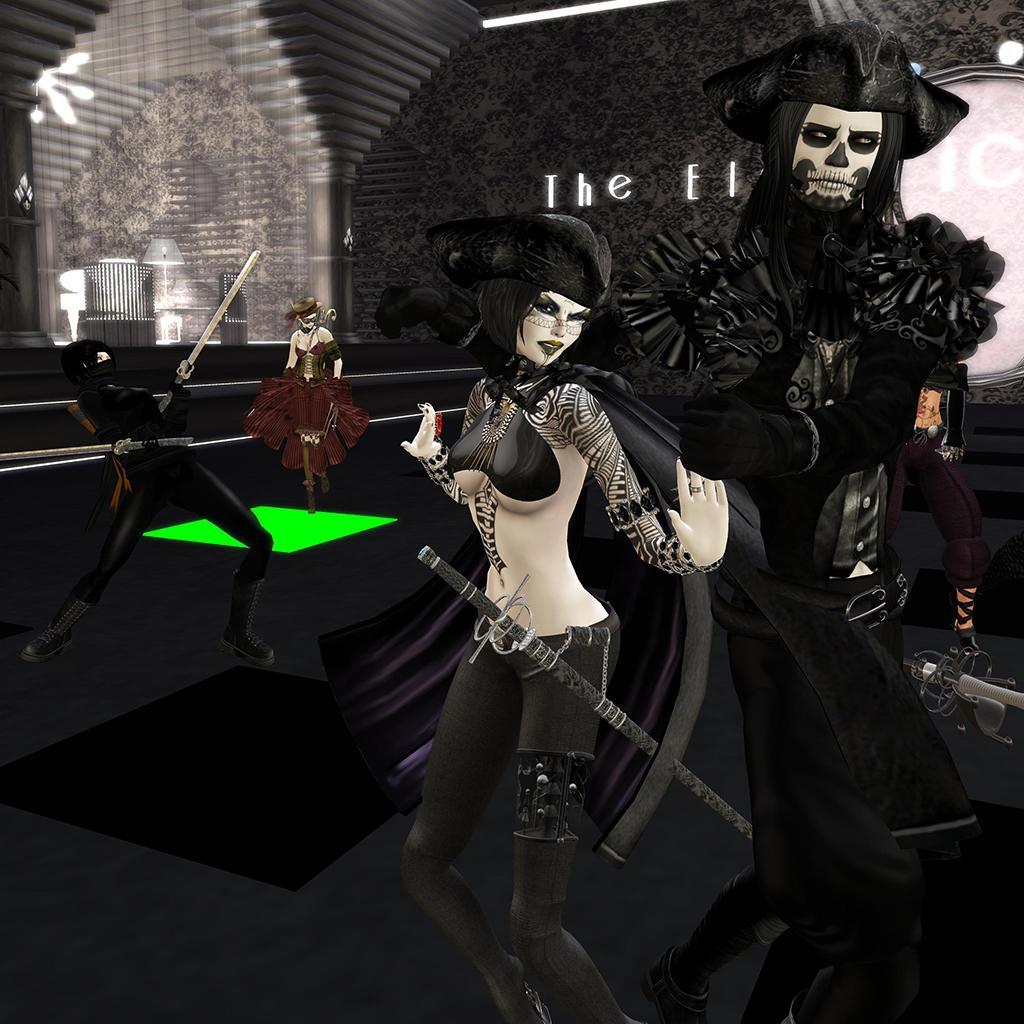Describe this image in one or two sentences. This is an animated image. In this picture, we see a woman standing in front of the picture. She has a sword. Behind her, the man in the black dress is stunning. Behind her, the man in black shirt is fighting with the sword. In the background, we see a wall in black color. 